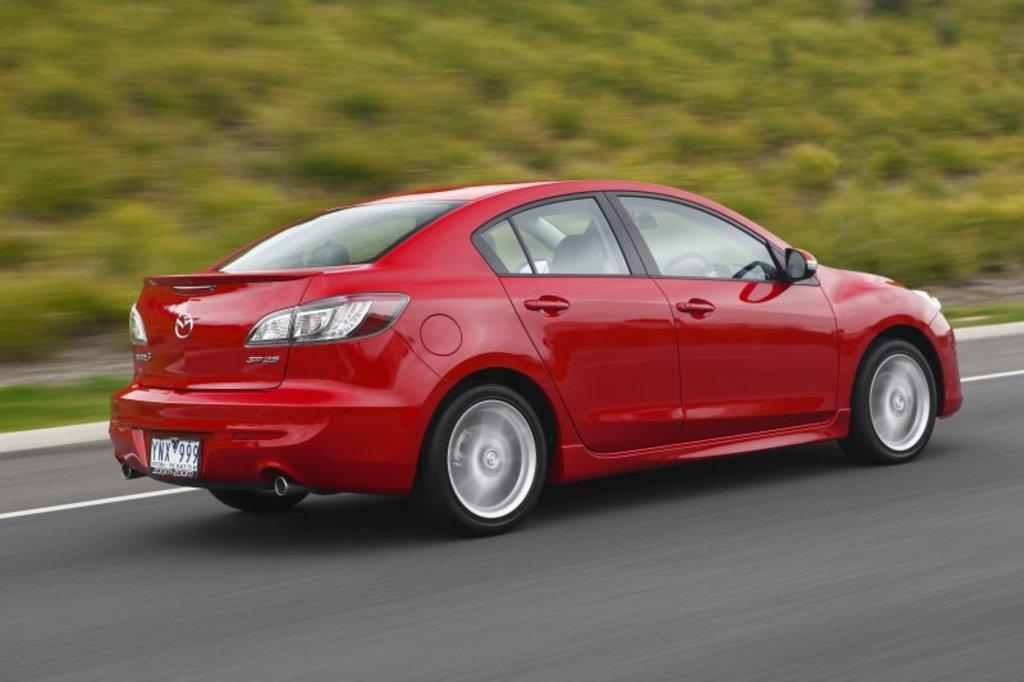What type of vehicle is in the image? There is a red car in the image. What is the car doing in the image? The car is moving on the road. What can be seen in the background of the image? There are plants and grass in the background of the image. What type of nose can be seen on the car in the image? Cars do not have noses; they have hoods and grilles. The image does not show any specific details about the car's front end. 